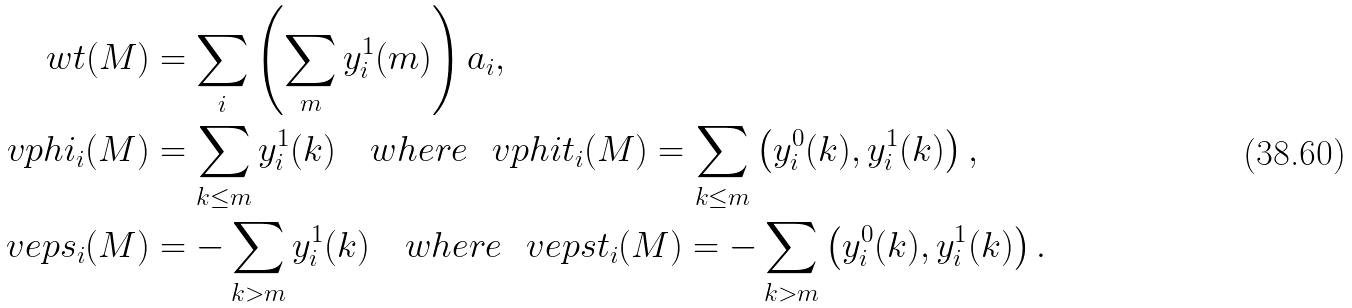Convert formula to latex. <formula><loc_0><loc_0><loc_500><loc_500>\ w t ( M ) & = \sum _ { i } \left ( \sum _ { m } y ^ { 1 } _ { i } ( m ) \right ) \L a _ { i } , \\ \ v p h i _ { i } ( M ) & = \sum _ { k \leq m } y ^ { 1 } _ { i } ( k ) \quad w h e r e \ \ v p h i t _ { i } ( M ) = \sum _ { k \leq m } \left ( y ^ { 0 } _ { i } ( k ) , y ^ { 1 } _ { i } ( k ) \right ) , \\ \ v e p s _ { i } ( M ) & = - \sum _ { k > m } y ^ { 1 } _ { i } ( k ) \quad w h e r e \ \ v e p s t _ { i } ( M ) = - \sum _ { k > m } \left ( y ^ { 0 } _ { i } ( k ) , y ^ { 1 } _ { i } ( k ) \right ) .</formula> 